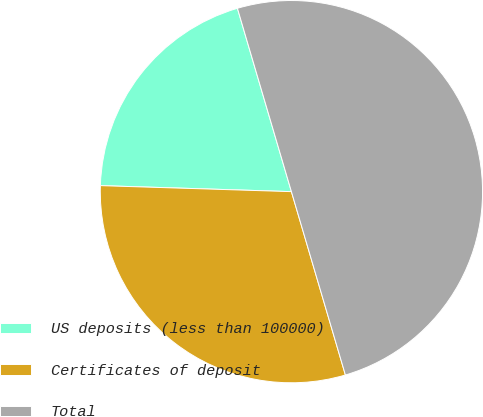<chart> <loc_0><loc_0><loc_500><loc_500><pie_chart><fcel>US deposits (less than 100000)<fcel>Certificates of deposit<fcel>Total<nl><fcel>19.94%<fcel>30.06%<fcel>50.0%<nl></chart> 